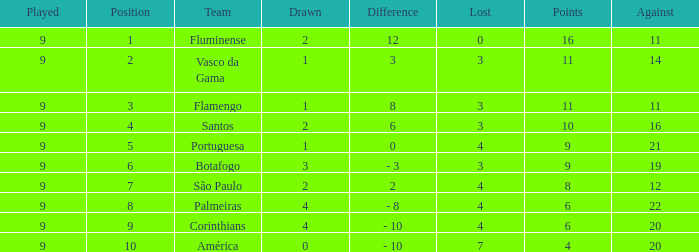Which Lost is the highest one that has a Drawn smaller than 4, and a Played smaller than 9? None. Would you mind parsing the complete table? {'header': ['Played', 'Position', 'Team', 'Drawn', 'Difference', 'Lost', 'Points', 'Against'], 'rows': [['9', '1', 'Fluminense', '2', '12', '0', '16', '11'], ['9', '2', 'Vasco da Gama', '1', '3', '3', '11', '14'], ['9', '3', 'Flamengo', '1', '8', '3', '11', '11'], ['9', '4', 'Santos', '2', '6', '3', '10', '16'], ['9', '5', 'Portuguesa', '1', '0', '4', '9', '21'], ['9', '6', 'Botafogo', '3', '- 3', '3', '9', '19'], ['9', '7', 'São Paulo', '2', '2', '4', '8', '12'], ['9', '8', 'Palmeiras', '4', '- 8', '4', '6', '22'], ['9', '9', 'Corinthians', '4', '- 10', '4', '6', '20'], ['9', '10', 'América', '0', '- 10', '7', '4', '20']]} 